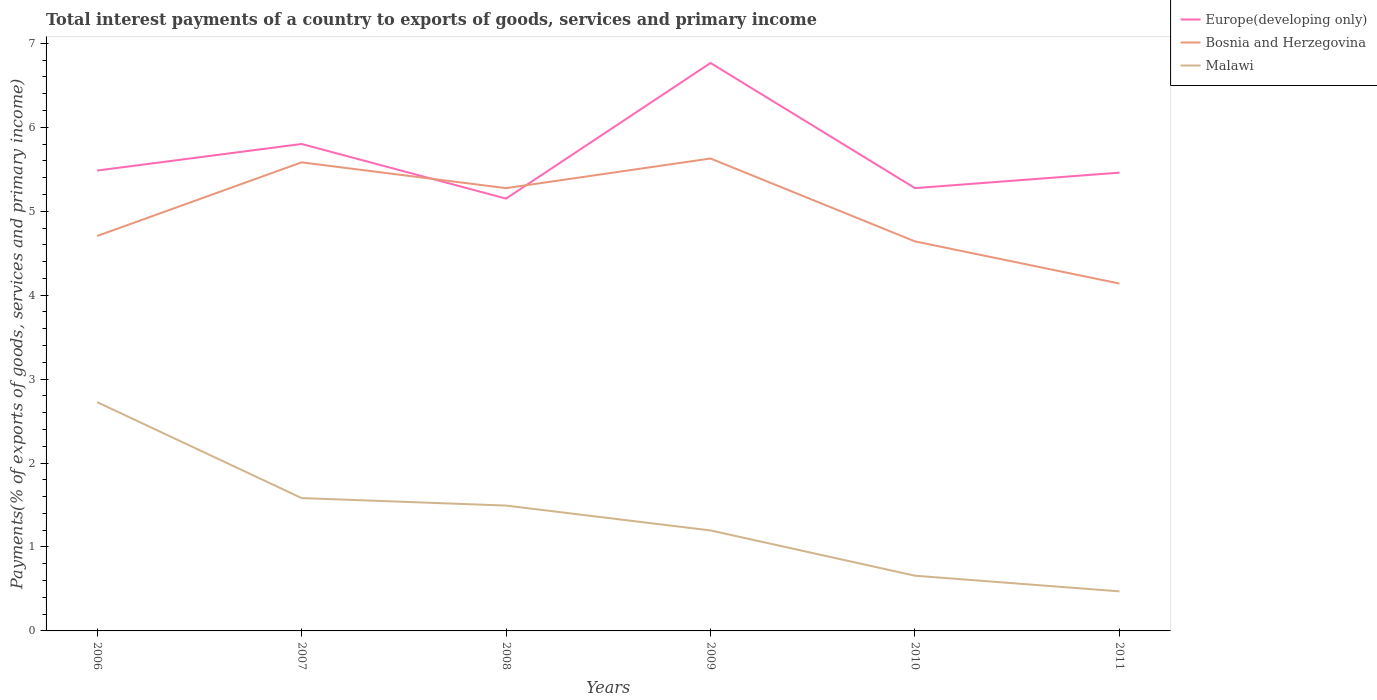Is the number of lines equal to the number of legend labels?
Ensure brevity in your answer.  Yes. Across all years, what is the maximum total interest payments in Bosnia and Herzegovina?
Your answer should be compact. 4.14. What is the total total interest payments in Europe(developing only) in the graph?
Keep it short and to the point. -0.18. What is the difference between the highest and the second highest total interest payments in Malawi?
Your answer should be very brief. 2.25. Is the total interest payments in Europe(developing only) strictly greater than the total interest payments in Malawi over the years?
Keep it short and to the point. No. How many lines are there?
Your answer should be very brief. 3. Does the graph contain any zero values?
Give a very brief answer. No. Does the graph contain grids?
Keep it short and to the point. No. Where does the legend appear in the graph?
Provide a succinct answer. Top right. What is the title of the graph?
Your response must be concise. Total interest payments of a country to exports of goods, services and primary income. Does "Paraguay" appear as one of the legend labels in the graph?
Ensure brevity in your answer.  No. What is the label or title of the Y-axis?
Offer a terse response. Payments(% of exports of goods, services and primary income). What is the Payments(% of exports of goods, services and primary income) of Europe(developing only) in 2006?
Make the answer very short. 5.49. What is the Payments(% of exports of goods, services and primary income) of Bosnia and Herzegovina in 2006?
Provide a short and direct response. 4.71. What is the Payments(% of exports of goods, services and primary income) of Malawi in 2006?
Provide a succinct answer. 2.73. What is the Payments(% of exports of goods, services and primary income) of Europe(developing only) in 2007?
Offer a very short reply. 5.8. What is the Payments(% of exports of goods, services and primary income) in Bosnia and Herzegovina in 2007?
Make the answer very short. 5.58. What is the Payments(% of exports of goods, services and primary income) in Malawi in 2007?
Offer a terse response. 1.58. What is the Payments(% of exports of goods, services and primary income) of Europe(developing only) in 2008?
Provide a succinct answer. 5.15. What is the Payments(% of exports of goods, services and primary income) of Bosnia and Herzegovina in 2008?
Your answer should be very brief. 5.28. What is the Payments(% of exports of goods, services and primary income) in Malawi in 2008?
Offer a very short reply. 1.49. What is the Payments(% of exports of goods, services and primary income) of Europe(developing only) in 2009?
Give a very brief answer. 6.77. What is the Payments(% of exports of goods, services and primary income) of Bosnia and Herzegovina in 2009?
Provide a short and direct response. 5.63. What is the Payments(% of exports of goods, services and primary income) of Malawi in 2009?
Provide a short and direct response. 1.2. What is the Payments(% of exports of goods, services and primary income) in Europe(developing only) in 2010?
Your response must be concise. 5.28. What is the Payments(% of exports of goods, services and primary income) of Bosnia and Herzegovina in 2010?
Your response must be concise. 4.64. What is the Payments(% of exports of goods, services and primary income) of Malawi in 2010?
Offer a terse response. 0.66. What is the Payments(% of exports of goods, services and primary income) in Europe(developing only) in 2011?
Make the answer very short. 5.46. What is the Payments(% of exports of goods, services and primary income) in Bosnia and Herzegovina in 2011?
Provide a short and direct response. 4.14. What is the Payments(% of exports of goods, services and primary income) of Malawi in 2011?
Your answer should be very brief. 0.47. Across all years, what is the maximum Payments(% of exports of goods, services and primary income) of Europe(developing only)?
Make the answer very short. 6.77. Across all years, what is the maximum Payments(% of exports of goods, services and primary income) in Bosnia and Herzegovina?
Your answer should be very brief. 5.63. Across all years, what is the maximum Payments(% of exports of goods, services and primary income) of Malawi?
Provide a succinct answer. 2.73. Across all years, what is the minimum Payments(% of exports of goods, services and primary income) in Europe(developing only)?
Ensure brevity in your answer.  5.15. Across all years, what is the minimum Payments(% of exports of goods, services and primary income) of Bosnia and Herzegovina?
Ensure brevity in your answer.  4.14. Across all years, what is the minimum Payments(% of exports of goods, services and primary income) in Malawi?
Make the answer very short. 0.47. What is the total Payments(% of exports of goods, services and primary income) in Europe(developing only) in the graph?
Keep it short and to the point. 33.94. What is the total Payments(% of exports of goods, services and primary income) of Bosnia and Herzegovina in the graph?
Offer a very short reply. 29.97. What is the total Payments(% of exports of goods, services and primary income) of Malawi in the graph?
Make the answer very short. 8.13. What is the difference between the Payments(% of exports of goods, services and primary income) in Europe(developing only) in 2006 and that in 2007?
Your answer should be compact. -0.32. What is the difference between the Payments(% of exports of goods, services and primary income) of Bosnia and Herzegovina in 2006 and that in 2007?
Give a very brief answer. -0.88. What is the difference between the Payments(% of exports of goods, services and primary income) in Malawi in 2006 and that in 2007?
Your answer should be compact. 1.14. What is the difference between the Payments(% of exports of goods, services and primary income) of Europe(developing only) in 2006 and that in 2008?
Provide a short and direct response. 0.33. What is the difference between the Payments(% of exports of goods, services and primary income) in Bosnia and Herzegovina in 2006 and that in 2008?
Offer a very short reply. -0.57. What is the difference between the Payments(% of exports of goods, services and primary income) in Malawi in 2006 and that in 2008?
Provide a short and direct response. 1.23. What is the difference between the Payments(% of exports of goods, services and primary income) of Europe(developing only) in 2006 and that in 2009?
Offer a very short reply. -1.28. What is the difference between the Payments(% of exports of goods, services and primary income) of Bosnia and Herzegovina in 2006 and that in 2009?
Provide a succinct answer. -0.92. What is the difference between the Payments(% of exports of goods, services and primary income) in Malawi in 2006 and that in 2009?
Make the answer very short. 1.53. What is the difference between the Payments(% of exports of goods, services and primary income) in Europe(developing only) in 2006 and that in 2010?
Offer a terse response. 0.21. What is the difference between the Payments(% of exports of goods, services and primary income) in Bosnia and Herzegovina in 2006 and that in 2010?
Offer a very short reply. 0.06. What is the difference between the Payments(% of exports of goods, services and primary income) of Malawi in 2006 and that in 2010?
Ensure brevity in your answer.  2.07. What is the difference between the Payments(% of exports of goods, services and primary income) of Europe(developing only) in 2006 and that in 2011?
Keep it short and to the point. 0.02. What is the difference between the Payments(% of exports of goods, services and primary income) in Bosnia and Herzegovina in 2006 and that in 2011?
Your answer should be very brief. 0.57. What is the difference between the Payments(% of exports of goods, services and primary income) in Malawi in 2006 and that in 2011?
Your response must be concise. 2.25. What is the difference between the Payments(% of exports of goods, services and primary income) in Europe(developing only) in 2007 and that in 2008?
Offer a very short reply. 0.65. What is the difference between the Payments(% of exports of goods, services and primary income) in Bosnia and Herzegovina in 2007 and that in 2008?
Your answer should be compact. 0.31. What is the difference between the Payments(% of exports of goods, services and primary income) in Malawi in 2007 and that in 2008?
Provide a short and direct response. 0.09. What is the difference between the Payments(% of exports of goods, services and primary income) in Europe(developing only) in 2007 and that in 2009?
Your answer should be very brief. -0.97. What is the difference between the Payments(% of exports of goods, services and primary income) of Bosnia and Herzegovina in 2007 and that in 2009?
Provide a short and direct response. -0.05. What is the difference between the Payments(% of exports of goods, services and primary income) of Malawi in 2007 and that in 2009?
Ensure brevity in your answer.  0.39. What is the difference between the Payments(% of exports of goods, services and primary income) in Europe(developing only) in 2007 and that in 2010?
Provide a succinct answer. 0.53. What is the difference between the Payments(% of exports of goods, services and primary income) of Bosnia and Herzegovina in 2007 and that in 2010?
Your answer should be compact. 0.94. What is the difference between the Payments(% of exports of goods, services and primary income) in Malawi in 2007 and that in 2010?
Your response must be concise. 0.93. What is the difference between the Payments(% of exports of goods, services and primary income) in Europe(developing only) in 2007 and that in 2011?
Provide a short and direct response. 0.34. What is the difference between the Payments(% of exports of goods, services and primary income) in Bosnia and Herzegovina in 2007 and that in 2011?
Make the answer very short. 1.44. What is the difference between the Payments(% of exports of goods, services and primary income) of Malawi in 2007 and that in 2011?
Your answer should be very brief. 1.11. What is the difference between the Payments(% of exports of goods, services and primary income) in Europe(developing only) in 2008 and that in 2009?
Provide a short and direct response. -1.62. What is the difference between the Payments(% of exports of goods, services and primary income) of Bosnia and Herzegovina in 2008 and that in 2009?
Give a very brief answer. -0.35. What is the difference between the Payments(% of exports of goods, services and primary income) in Malawi in 2008 and that in 2009?
Keep it short and to the point. 0.3. What is the difference between the Payments(% of exports of goods, services and primary income) in Europe(developing only) in 2008 and that in 2010?
Ensure brevity in your answer.  -0.12. What is the difference between the Payments(% of exports of goods, services and primary income) of Bosnia and Herzegovina in 2008 and that in 2010?
Offer a very short reply. 0.63. What is the difference between the Payments(% of exports of goods, services and primary income) of Malawi in 2008 and that in 2010?
Offer a very short reply. 0.84. What is the difference between the Payments(% of exports of goods, services and primary income) in Europe(developing only) in 2008 and that in 2011?
Offer a very short reply. -0.31. What is the difference between the Payments(% of exports of goods, services and primary income) in Bosnia and Herzegovina in 2008 and that in 2011?
Your response must be concise. 1.14. What is the difference between the Payments(% of exports of goods, services and primary income) of Malawi in 2008 and that in 2011?
Your response must be concise. 1.02. What is the difference between the Payments(% of exports of goods, services and primary income) in Europe(developing only) in 2009 and that in 2010?
Ensure brevity in your answer.  1.49. What is the difference between the Payments(% of exports of goods, services and primary income) of Bosnia and Herzegovina in 2009 and that in 2010?
Provide a succinct answer. 0.99. What is the difference between the Payments(% of exports of goods, services and primary income) in Malawi in 2009 and that in 2010?
Your answer should be very brief. 0.54. What is the difference between the Payments(% of exports of goods, services and primary income) of Europe(developing only) in 2009 and that in 2011?
Provide a succinct answer. 1.31. What is the difference between the Payments(% of exports of goods, services and primary income) of Bosnia and Herzegovina in 2009 and that in 2011?
Make the answer very short. 1.49. What is the difference between the Payments(% of exports of goods, services and primary income) of Malawi in 2009 and that in 2011?
Provide a succinct answer. 0.73. What is the difference between the Payments(% of exports of goods, services and primary income) of Europe(developing only) in 2010 and that in 2011?
Keep it short and to the point. -0.18. What is the difference between the Payments(% of exports of goods, services and primary income) in Bosnia and Herzegovina in 2010 and that in 2011?
Your response must be concise. 0.5. What is the difference between the Payments(% of exports of goods, services and primary income) in Malawi in 2010 and that in 2011?
Offer a very short reply. 0.19. What is the difference between the Payments(% of exports of goods, services and primary income) in Europe(developing only) in 2006 and the Payments(% of exports of goods, services and primary income) in Bosnia and Herzegovina in 2007?
Provide a short and direct response. -0.1. What is the difference between the Payments(% of exports of goods, services and primary income) in Europe(developing only) in 2006 and the Payments(% of exports of goods, services and primary income) in Malawi in 2007?
Offer a very short reply. 3.9. What is the difference between the Payments(% of exports of goods, services and primary income) in Bosnia and Herzegovina in 2006 and the Payments(% of exports of goods, services and primary income) in Malawi in 2007?
Provide a short and direct response. 3.12. What is the difference between the Payments(% of exports of goods, services and primary income) in Europe(developing only) in 2006 and the Payments(% of exports of goods, services and primary income) in Bosnia and Herzegovina in 2008?
Offer a very short reply. 0.21. What is the difference between the Payments(% of exports of goods, services and primary income) of Europe(developing only) in 2006 and the Payments(% of exports of goods, services and primary income) of Malawi in 2008?
Give a very brief answer. 3.99. What is the difference between the Payments(% of exports of goods, services and primary income) in Bosnia and Herzegovina in 2006 and the Payments(% of exports of goods, services and primary income) in Malawi in 2008?
Your response must be concise. 3.21. What is the difference between the Payments(% of exports of goods, services and primary income) of Europe(developing only) in 2006 and the Payments(% of exports of goods, services and primary income) of Bosnia and Herzegovina in 2009?
Make the answer very short. -0.14. What is the difference between the Payments(% of exports of goods, services and primary income) of Europe(developing only) in 2006 and the Payments(% of exports of goods, services and primary income) of Malawi in 2009?
Your response must be concise. 4.29. What is the difference between the Payments(% of exports of goods, services and primary income) in Bosnia and Herzegovina in 2006 and the Payments(% of exports of goods, services and primary income) in Malawi in 2009?
Give a very brief answer. 3.51. What is the difference between the Payments(% of exports of goods, services and primary income) of Europe(developing only) in 2006 and the Payments(% of exports of goods, services and primary income) of Bosnia and Herzegovina in 2010?
Your answer should be very brief. 0.84. What is the difference between the Payments(% of exports of goods, services and primary income) in Europe(developing only) in 2006 and the Payments(% of exports of goods, services and primary income) in Malawi in 2010?
Your answer should be very brief. 4.83. What is the difference between the Payments(% of exports of goods, services and primary income) in Bosnia and Herzegovina in 2006 and the Payments(% of exports of goods, services and primary income) in Malawi in 2010?
Provide a short and direct response. 4.05. What is the difference between the Payments(% of exports of goods, services and primary income) in Europe(developing only) in 2006 and the Payments(% of exports of goods, services and primary income) in Bosnia and Herzegovina in 2011?
Your answer should be very brief. 1.35. What is the difference between the Payments(% of exports of goods, services and primary income) in Europe(developing only) in 2006 and the Payments(% of exports of goods, services and primary income) in Malawi in 2011?
Your answer should be very brief. 5.01. What is the difference between the Payments(% of exports of goods, services and primary income) in Bosnia and Herzegovina in 2006 and the Payments(% of exports of goods, services and primary income) in Malawi in 2011?
Offer a very short reply. 4.23. What is the difference between the Payments(% of exports of goods, services and primary income) in Europe(developing only) in 2007 and the Payments(% of exports of goods, services and primary income) in Bosnia and Herzegovina in 2008?
Ensure brevity in your answer.  0.53. What is the difference between the Payments(% of exports of goods, services and primary income) in Europe(developing only) in 2007 and the Payments(% of exports of goods, services and primary income) in Malawi in 2008?
Your answer should be compact. 4.31. What is the difference between the Payments(% of exports of goods, services and primary income) in Bosnia and Herzegovina in 2007 and the Payments(% of exports of goods, services and primary income) in Malawi in 2008?
Provide a short and direct response. 4.09. What is the difference between the Payments(% of exports of goods, services and primary income) in Europe(developing only) in 2007 and the Payments(% of exports of goods, services and primary income) in Bosnia and Herzegovina in 2009?
Offer a very short reply. 0.17. What is the difference between the Payments(% of exports of goods, services and primary income) of Europe(developing only) in 2007 and the Payments(% of exports of goods, services and primary income) of Malawi in 2009?
Offer a terse response. 4.6. What is the difference between the Payments(% of exports of goods, services and primary income) in Bosnia and Herzegovina in 2007 and the Payments(% of exports of goods, services and primary income) in Malawi in 2009?
Offer a very short reply. 4.39. What is the difference between the Payments(% of exports of goods, services and primary income) of Europe(developing only) in 2007 and the Payments(% of exports of goods, services and primary income) of Bosnia and Herzegovina in 2010?
Your response must be concise. 1.16. What is the difference between the Payments(% of exports of goods, services and primary income) of Europe(developing only) in 2007 and the Payments(% of exports of goods, services and primary income) of Malawi in 2010?
Make the answer very short. 5.14. What is the difference between the Payments(% of exports of goods, services and primary income) of Bosnia and Herzegovina in 2007 and the Payments(% of exports of goods, services and primary income) of Malawi in 2010?
Provide a short and direct response. 4.93. What is the difference between the Payments(% of exports of goods, services and primary income) of Europe(developing only) in 2007 and the Payments(% of exports of goods, services and primary income) of Bosnia and Herzegovina in 2011?
Keep it short and to the point. 1.66. What is the difference between the Payments(% of exports of goods, services and primary income) of Europe(developing only) in 2007 and the Payments(% of exports of goods, services and primary income) of Malawi in 2011?
Offer a terse response. 5.33. What is the difference between the Payments(% of exports of goods, services and primary income) in Bosnia and Herzegovina in 2007 and the Payments(% of exports of goods, services and primary income) in Malawi in 2011?
Your answer should be compact. 5.11. What is the difference between the Payments(% of exports of goods, services and primary income) in Europe(developing only) in 2008 and the Payments(% of exports of goods, services and primary income) in Bosnia and Herzegovina in 2009?
Provide a succinct answer. -0.48. What is the difference between the Payments(% of exports of goods, services and primary income) in Europe(developing only) in 2008 and the Payments(% of exports of goods, services and primary income) in Malawi in 2009?
Make the answer very short. 3.95. What is the difference between the Payments(% of exports of goods, services and primary income) of Bosnia and Herzegovina in 2008 and the Payments(% of exports of goods, services and primary income) of Malawi in 2009?
Give a very brief answer. 4.08. What is the difference between the Payments(% of exports of goods, services and primary income) of Europe(developing only) in 2008 and the Payments(% of exports of goods, services and primary income) of Bosnia and Herzegovina in 2010?
Ensure brevity in your answer.  0.51. What is the difference between the Payments(% of exports of goods, services and primary income) of Europe(developing only) in 2008 and the Payments(% of exports of goods, services and primary income) of Malawi in 2010?
Ensure brevity in your answer.  4.49. What is the difference between the Payments(% of exports of goods, services and primary income) of Bosnia and Herzegovina in 2008 and the Payments(% of exports of goods, services and primary income) of Malawi in 2010?
Keep it short and to the point. 4.62. What is the difference between the Payments(% of exports of goods, services and primary income) in Europe(developing only) in 2008 and the Payments(% of exports of goods, services and primary income) in Bosnia and Herzegovina in 2011?
Give a very brief answer. 1.01. What is the difference between the Payments(% of exports of goods, services and primary income) of Europe(developing only) in 2008 and the Payments(% of exports of goods, services and primary income) of Malawi in 2011?
Provide a succinct answer. 4.68. What is the difference between the Payments(% of exports of goods, services and primary income) of Bosnia and Herzegovina in 2008 and the Payments(% of exports of goods, services and primary income) of Malawi in 2011?
Your answer should be compact. 4.8. What is the difference between the Payments(% of exports of goods, services and primary income) of Europe(developing only) in 2009 and the Payments(% of exports of goods, services and primary income) of Bosnia and Herzegovina in 2010?
Keep it short and to the point. 2.13. What is the difference between the Payments(% of exports of goods, services and primary income) of Europe(developing only) in 2009 and the Payments(% of exports of goods, services and primary income) of Malawi in 2010?
Your answer should be very brief. 6.11. What is the difference between the Payments(% of exports of goods, services and primary income) of Bosnia and Herzegovina in 2009 and the Payments(% of exports of goods, services and primary income) of Malawi in 2010?
Your answer should be very brief. 4.97. What is the difference between the Payments(% of exports of goods, services and primary income) of Europe(developing only) in 2009 and the Payments(% of exports of goods, services and primary income) of Bosnia and Herzegovina in 2011?
Ensure brevity in your answer.  2.63. What is the difference between the Payments(% of exports of goods, services and primary income) in Europe(developing only) in 2009 and the Payments(% of exports of goods, services and primary income) in Malawi in 2011?
Keep it short and to the point. 6.3. What is the difference between the Payments(% of exports of goods, services and primary income) in Bosnia and Herzegovina in 2009 and the Payments(% of exports of goods, services and primary income) in Malawi in 2011?
Offer a terse response. 5.16. What is the difference between the Payments(% of exports of goods, services and primary income) of Europe(developing only) in 2010 and the Payments(% of exports of goods, services and primary income) of Bosnia and Herzegovina in 2011?
Provide a succinct answer. 1.14. What is the difference between the Payments(% of exports of goods, services and primary income) of Europe(developing only) in 2010 and the Payments(% of exports of goods, services and primary income) of Malawi in 2011?
Provide a short and direct response. 4.8. What is the difference between the Payments(% of exports of goods, services and primary income) in Bosnia and Herzegovina in 2010 and the Payments(% of exports of goods, services and primary income) in Malawi in 2011?
Provide a succinct answer. 4.17. What is the average Payments(% of exports of goods, services and primary income) in Europe(developing only) per year?
Your response must be concise. 5.66. What is the average Payments(% of exports of goods, services and primary income) of Bosnia and Herzegovina per year?
Your response must be concise. 5. What is the average Payments(% of exports of goods, services and primary income) in Malawi per year?
Offer a terse response. 1.35. In the year 2006, what is the difference between the Payments(% of exports of goods, services and primary income) in Europe(developing only) and Payments(% of exports of goods, services and primary income) in Bosnia and Herzegovina?
Provide a short and direct response. 0.78. In the year 2006, what is the difference between the Payments(% of exports of goods, services and primary income) of Europe(developing only) and Payments(% of exports of goods, services and primary income) of Malawi?
Provide a succinct answer. 2.76. In the year 2006, what is the difference between the Payments(% of exports of goods, services and primary income) in Bosnia and Herzegovina and Payments(% of exports of goods, services and primary income) in Malawi?
Your answer should be very brief. 1.98. In the year 2007, what is the difference between the Payments(% of exports of goods, services and primary income) in Europe(developing only) and Payments(% of exports of goods, services and primary income) in Bosnia and Herzegovina?
Your answer should be compact. 0.22. In the year 2007, what is the difference between the Payments(% of exports of goods, services and primary income) of Europe(developing only) and Payments(% of exports of goods, services and primary income) of Malawi?
Keep it short and to the point. 4.22. In the year 2007, what is the difference between the Payments(% of exports of goods, services and primary income) of Bosnia and Herzegovina and Payments(% of exports of goods, services and primary income) of Malawi?
Keep it short and to the point. 4. In the year 2008, what is the difference between the Payments(% of exports of goods, services and primary income) in Europe(developing only) and Payments(% of exports of goods, services and primary income) in Bosnia and Herzegovina?
Your answer should be compact. -0.12. In the year 2008, what is the difference between the Payments(% of exports of goods, services and primary income) of Europe(developing only) and Payments(% of exports of goods, services and primary income) of Malawi?
Keep it short and to the point. 3.66. In the year 2008, what is the difference between the Payments(% of exports of goods, services and primary income) in Bosnia and Herzegovina and Payments(% of exports of goods, services and primary income) in Malawi?
Provide a short and direct response. 3.78. In the year 2009, what is the difference between the Payments(% of exports of goods, services and primary income) of Europe(developing only) and Payments(% of exports of goods, services and primary income) of Bosnia and Herzegovina?
Keep it short and to the point. 1.14. In the year 2009, what is the difference between the Payments(% of exports of goods, services and primary income) of Europe(developing only) and Payments(% of exports of goods, services and primary income) of Malawi?
Offer a very short reply. 5.57. In the year 2009, what is the difference between the Payments(% of exports of goods, services and primary income) in Bosnia and Herzegovina and Payments(% of exports of goods, services and primary income) in Malawi?
Your answer should be compact. 4.43. In the year 2010, what is the difference between the Payments(% of exports of goods, services and primary income) in Europe(developing only) and Payments(% of exports of goods, services and primary income) in Bosnia and Herzegovina?
Your answer should be compact. 0.63. In the year 2010, what is the difference between the Payments(% of exports of goods, services and primary income) of Europe(developing only) and Payments(% of exports of goods, services and primary income) of Malawi?
Offer a terse response. 4.62. In the year 2010, what is the difference between the Payments(% of exports of goods, services and primary income) of Bosnia and Herzegovina and Payments(% of exports of goods, services and primary income) of Malawi?
Ensure brevity in your answer.  3.98. In the year 2011, what is the difference between the Payments(% of exports of goods, services and primary income) of Europe(developing only) and Payments(% of exports of goods, services and primary income) of Bosnia and Herzegovina?
Keep it short and to the point. 1.32. In the year 2011, what is the difference between the Payments(% of exports of goods, services and primary income) in Europe(developing only) and Payments(% of exports of goods, services and primary income) in Malawi?
Give a very brief answer. 4.99. In the year 2011, what is the difference between the Payments(% of exports of goods, services and primary income) of Bosnia and Herzegovina and Payments(% of exports of goods, services and primary income) of Malawi?
Your answer should be compact. 3.67. What is the ratio of the Payments(% of exports of goods, services and primary income) in Europe(developing only) in 2006 to that in 2007?
Your response must be concise. 0.95. What is the ratio of the Payments(% of exports of goods, services and primary income) of Bosnia and Herzegovina in 2006 to that in 2007?
Your answer should be compact. 0.84. What is the ratio of the Payments(% of exports of goods, services and primary income) of Malawi in 2006 to that in 2007?
Your answer should be very brief. 1.72. What is the ratio of the Payments(% of exports of goods, services and primary income) of Europe(developing only) in 2006 to that in 2008?
Provide a succinct answer. 1.06. What is the ratio of the Payments(% of exports of goods, services and primary income) in Bosnia and Herzegovina in 2006 to that in 2008?
Provide a short and direct response. 0.89. What is the ratio of the Payments(% of exports of goods, services and primary income) of Malawi in 2006 to that in 2008?
Keep it short and to the point. 1.83. What is the ratio of the Payments(% of exports of goods, services and primary income) in Europe(developing only) in 2006 to that in 2009?
Your response must be concise. 0.81. What is the ratio of the Payments(% of exports of goods, services and primary income) of Bosnia and Herzegovina in 2006 to that in 2009?
Your response must be concise. 0.84. What is the ratio of the Payments(% of exports of goods, services and primary income) in Malawi in 2006 to that in 2009?
Offer a terse response. 2.28. What is the ratio of the Payments(% of exports of goods, services and primary income) of Europe(developing only) in 2006 to that in 2010?
Your response must be concise. 1.04. What is the ratio of the Payments(% of exports of goods, services and primary income) of Bosnia and Herzegovina in 2006 to that in 2010?
Provide a succinct answer. 1.01. What is the ratio of the Payments(% of exports of goods, services and primary income) of Malawi in 2006 to that in 2010?
Your response must be concise. 4.14. What is the ratio of the Payments(% of exports of goods, services and primary income) in Europe(developing only) in 2006 to that in 2011?
Offer a terse response. 1. What is the ratio of the Payments(% of exports of goods, services and primary income) in Bosnia and Herzegovina in 2006 to that in 2011?
Provide a succinct answer. 1.14. What is the ratio of the Payments(% of exports of goods, services and primary income) in Malawi in 2006 to that in 2011?
Offer a terse response. 5.78. What is the ratio of the Payments(% of exports of goods, services and primary income) in Europe(developing only) in 2007 to that in 2008?
Offer a very short reply. 1.13. What is the ratio of the Payments(% of exports of goods, services and primary income) in Bosnia and Herzegovina in 2007 to that in 2008?
Your response must be concise. 1.06. What is the ratio of the Payments(% of exports of goods, services and primary income) of Malawi in 2007 to that in 2008?
Make the answer very short. 1.06. What is the ratio of the Payments(% of exports of goods, services and primary income) of Europe(developing only) in 2007 to that in 2009?
Your answer should be compact. 0.86. What is the ratio of the Payments(% of exports of goods, services and primary income) in Malawi in 2007 to that in 2009?
Your answer should be compact. 1.32. What is the ratio of the Payments(% of exports of goods, services and primary income) of Europe(developing only) in 2007 to that in 2010?
Offer a very short reply. 1.1. What is the ratio of the Payments(% of exports of goods, services and primary income) in Bosnia and Herzegovina in 2007 to that in 2010?
Your answer should be very brief. 1.2. What is the ratio of the Payments(% of exports of goods, services and primary income) of Malawi in 2007 to that in 2010?
Ensure brevity in your answer.  2.41. What is the ratio of the Payments(% of exports of goods, services and primary income) in Europe(developing only) in 2007 to that in 2011?
Your answer should be compact. 1.06. What is the ratio of the Payments(% of exports of goods, services and primary income) of Bosnia and Herzegovina in 2007 to that in 2011?
Give a very brief answer. 1.35. What is the ratio of the Payments(% of exports of goods, services and primary income) in Malawi in 2007 to that in 2011?
Provide a succinct answer. 3.36. What is the ratio of the Payments(% of exports of goods, services and primary income) in Europe(developing only) in 2008 to that in 2009?
Ensure brevity in your answer.  0.76. What is the ratio of the Payments(% of exports of goods, services and primary income) of Bosnia and Herzegovina in 2008 to that in 2009?
Ensure brevity in your answer.  0.94. What is the ratio of the Payments(% of exports of goods, services and primary income) in Malawi in 2008 to that in 2009?
Your answer should be compact. 1.25. What is the ratio of the Payments(% of exports of goods, services and primary income) of Europe(developing only) in 2008 to that in 2010?
Ensure brevity in your answer.  0.98. What is the ratio of the Payments(% of exports of goods, services and primary income) of Bosnia and Herzegovina in 2008 to that in 2010?
Offer a very short reply. 1.14. What is the ratio of the Payments(% of exports of goods, services and primary income) in Malawi in 2008 to that in 2010?
Keep it short and to the point. 2.27. What is the ratio of the Payments(% of exports of goods, services and primary income) in Europe(developing only) in 2008 to that in 2011?
Offer a very short reply. 0.94. What is the ratio of the Payments(% of exports of goods, services and primary income) in Bosnia and Herzegovina in 2008 to that in 2011?
Offer a terse response. 1.27. What is the ratio of the Payments(% of exports of goods, services and primary income) in Malawi in 2008 to that in 2011?
Keep it short and to the point. 3.17. What is the ratio of the Payments(% of exports of goods, services and primary income) in Europe(developing only) in 2009 to that in 2010?
Provide a succinct answer. 1.28. What is the ratio of the Payments(% of exports of goods, services and primary income) in Bosnia and Herzegovina in 2009 to that in 2010?
Keep it short and to the point. 1.21. What is the ratio of the Payments(% of exports of goods, services and primary income) in Malawi in 2009 to that in 2010?
Make the answer very short. 1.82. What is the ratio of the Payments(% of exports of goods, services and primary income) of Europe(developing only) in 2009 to that in 2011?
Offer a terse response. 1.24. What is the ratio of the Payments(% of exports of goods, services and primary income) in Bosnia and Herzegovina in 2009 to that in 2011?
Your answer should be compact. 1.36. What is the ratio of the Payments(% of exports of goods, services and primary income) of Malawi in 2009 to that in 2011?
Provide a short and direct response. 2.54. What is the ratio of the Payments(% of exports of goods, services and primary income) in Europe(developing only) in 2010 to that in 2011?
Your answer should be compact. 0.97. What is the ratio of the Payments(% of exports of goods, services and primary income) in Bosnia and Herzegovina in 2010 to that in 2011?
Offer a very short reply. 1.12. What is the ratio of the Payments(% of exports of goods, services and primary income) in Malawi in 2010 to that in 2011?
Your response must be concise. 1.4. What is the difference between the highest and the second highest Payments(% of exports of goods, services and primary income) in Europe(developing only)?
Offer a terse response. 0.97. What is the difference between the highest and the second highest Payments(% of exports of goods, services and primary income) of Bosnia and Herzegovina?
Your answer should be very brief. 0.05. What is the difference between the highest and the second highest Payments(% of exports of goods, services and primary income) of Malawi?
Offer a very short reply. 1.14. What is the difference between the highest and the lowest Payments(% of exports of goods, services and primary income) in Europe(developing only)?
Make the answer very short. 1.62. What is the difference between the highest and the lowest Payments(% of exports of goods, services and primary income) in Bosnia and Herzegovina?
Offer a very short reply. 1.49. What is the difference between the highest and the lowest Payments(% of exports of goods, services and primary income) of Malawi?
Make the answer very short. 2.25. 